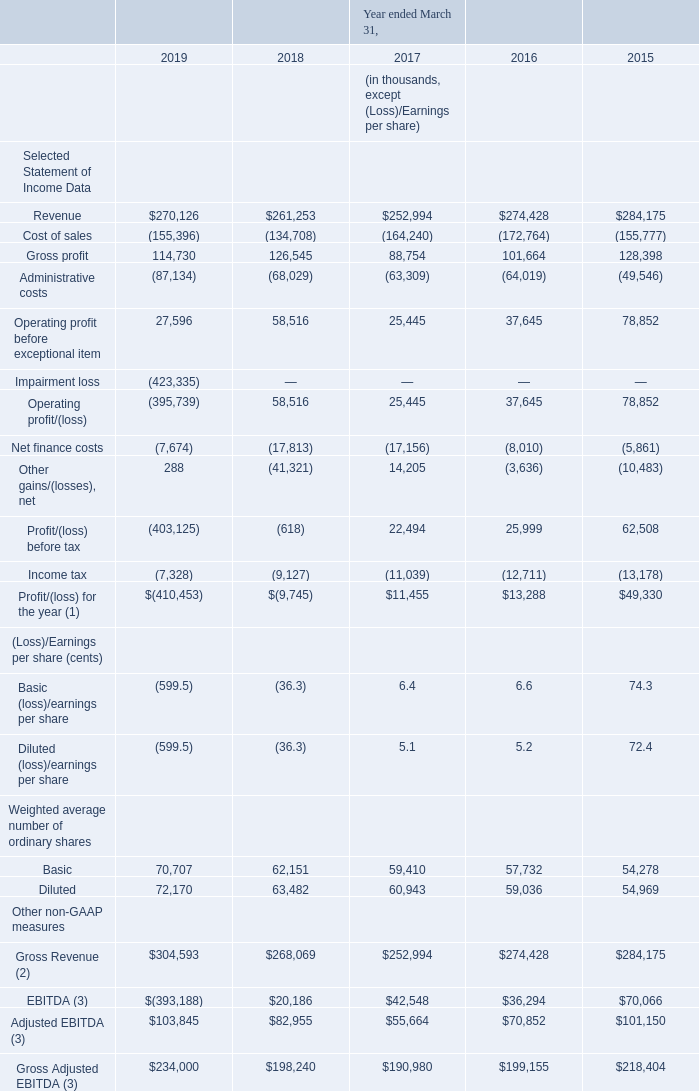A. Selected Financial Data The table set forth below presents our selected historical consolidated financial data for the periods and at the dates indicated. The selected historical consolidated statements of income data for each of the three years ended March 31, 2019, 2018, and 2017 and the selected statements of financial position data as of March 31, 2019 and 2018 have been derived from and should be read in conjunction with “Part I — Item 5.
Operating and Financial Review and Prospects” and our consolidated financial statements included elsewhere in this Annual Report on Form 20-F. The selected historical consolidated statements of income data for each of the two years ended March 31, 2016 and 2015 and the selected historical statements of financial position data as of March 31, 2017, 2016, and 2015 have been derived from audited consolidated financial statements not included in this Annual Report on Form 20-F.
(1) References to “net income” in this document correspond to “profit/(loss) for the period” or “profit/(loss) for the year” line items in our consolidated financial statement appearing elsewhere in this document. (2) Gross Revenue is defined as reported revenue adjusted in respect of significant financing component that arises on account of normal credit terms provided to catalogue customers.
(3) We use EBITDA, Adjusted EBITDA and Gross Adjusted EBITDA as supplemental financial measures. EBITDA is defined by us as net income before interest expense, income tax expense and depreciation and amortization (excluding amortization of capitalized film content and debt issuance costs).
Adjusted EBITDA is defined as EBITDA adjusted for (gain)/impairment of available-for-sale financial assets, profit/loss on held for trading liabilities (including profit/loss on derivative financial instruments), transactions costs relating to equity transactions, share based payments, Loss / (Gain) on sale of property and equipment, Loss on de-recognition of financial assets measured at amortized cost, net,
Credit impairment loss, net, Loss on financial liability (convertible notes) measured at fair value through profit and loss, Loss on deconsolidation of a subsidiary and exceptional items such as impairment of goodwill, trademark, film & content rights and content advances.
Gross Adjusted EBITDA is defined as Adjusted EBITDA adjusted for amortization of intangible films and content rights. EBITDA, Adjusted EBITDA and Gross Adjusted EBITDA as used and defined by us, may not be comparable to similarly-titled measures employed by other companies and is not a measure of performance calculated in accordance with GAAP.
EBITDA Adjusted EBITDA and Gross Adjusted EBITDA should not be considered in isolation or as a substitute for operating income, net income, cash flows from operating, investing and financing activities, or other income or cash flow statement data prepared in accordance with GAAP. EBITDA, Adjusted EBITDA and Gross Adjusted EBITDA provide no information regarding a Company’s capital structure, borrowings, interest costs, capital expenditures and working capital movement or tax position.
What is the definition of EBITDA as per the company? Ebitda is defined by us as net income before interest expense, income tax expense and depreciation and amortization (excluding amortization of capitalized film content and debt issuance costs). What information do EBITDA and Adjusted EBITDA provide regarding company's capital structure? Ebitda, adjusted ebitda and gross adjusted ebitda provide no information regarding a company’s capital structure, borrowings, interest costs, capital expenditures and working capital movement or tax position. What are the years included in the table? 2019, 2018, 2017, 2016, 2015. What is the increase / (decrease) in revenue from 2018 to 2019?
Answer scale should be: thousand. 270,126 - 261,253
Answer: 8873. What is the average gross profit?
Answer scale should be: thousand. (114,730 + 126,545 + 88,754 + 101,664 + 128,398) / 5
Answer: 112018.2. What is the percentage increase / (decrease) in the Operating profit before exceptional item from 2018 to 2019?
Answer scale should be: percent. 27,596 / 58,516 - 1
Answer: -52.84. 